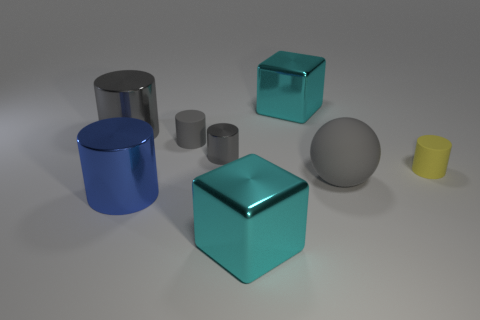Do the block in front of the small gray shiny thing and the sphere have the same color?
Provide a short and direct response. No. What number of spheres are big purple metallic objects or cyan things?
Your response must be concise. 0. There is a cyan metallic thing in front of the cyan thing that is behind the matte sphere; what shape is it?
Make the answer very short. Cube. There is a cyan block behind the large gray thing to the left of the big thing in front of the blue shiny object; how big is it?
Offer a terse response. Large. Do the gray ball and the blue shiny cylinder have the same size?
Your answer should be very brief. Yes. How many objects are either small shiny cylinders or large cylinders?
Provide a short and direct response. 3. There is a cyan metal cube that is behind the big gray object left of the tiny gray shiny cylinder; how big is it?
Your answer should be very brief. Large. What size is the yellow matte thing?
Offer a very short reply. Small. What is the shape of the large object that is both behind the blue thing and in front of the gray rubber cylinder?
Your response must be concise. Sphere. The small metal object that is the same shape as the big blue metal thing is what color?
Offer a very short reply. Gray. 